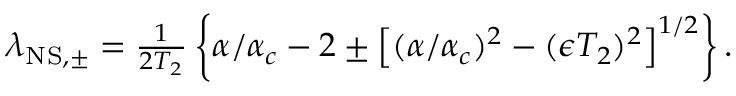<formula> <loc_0><loc_0><loc_500><loc_500>\begin{array} { r } { \lambda _ { N S , \pm } = \frac { 1 } { 2 T _ { 2 } } \left \{ \alpha / \alpha _ { c } - 2 \pm \left [ ( \alpha / \alpha _ { c } ) ^ { 2 } - ( \epsilon T _ { 2 } ) ^ { 2 } \right ] ^ { 1 / 2 } \right \} . } \end{array}</formula> 